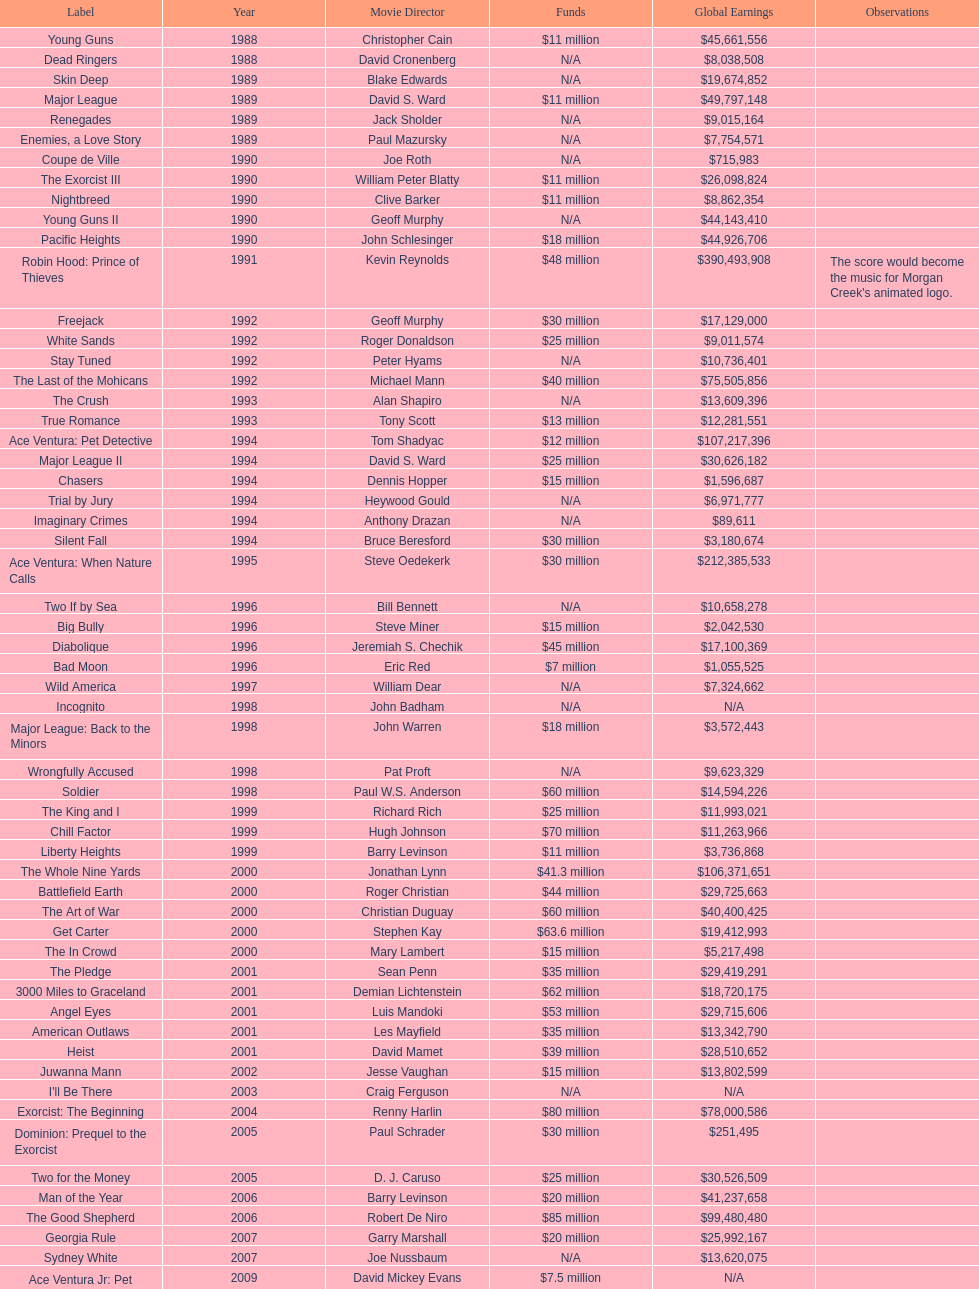Which film had a higher budget, ace ventura: when nature calls, or major league: back to the minors? Ace Ventura: When Nature Calls. 